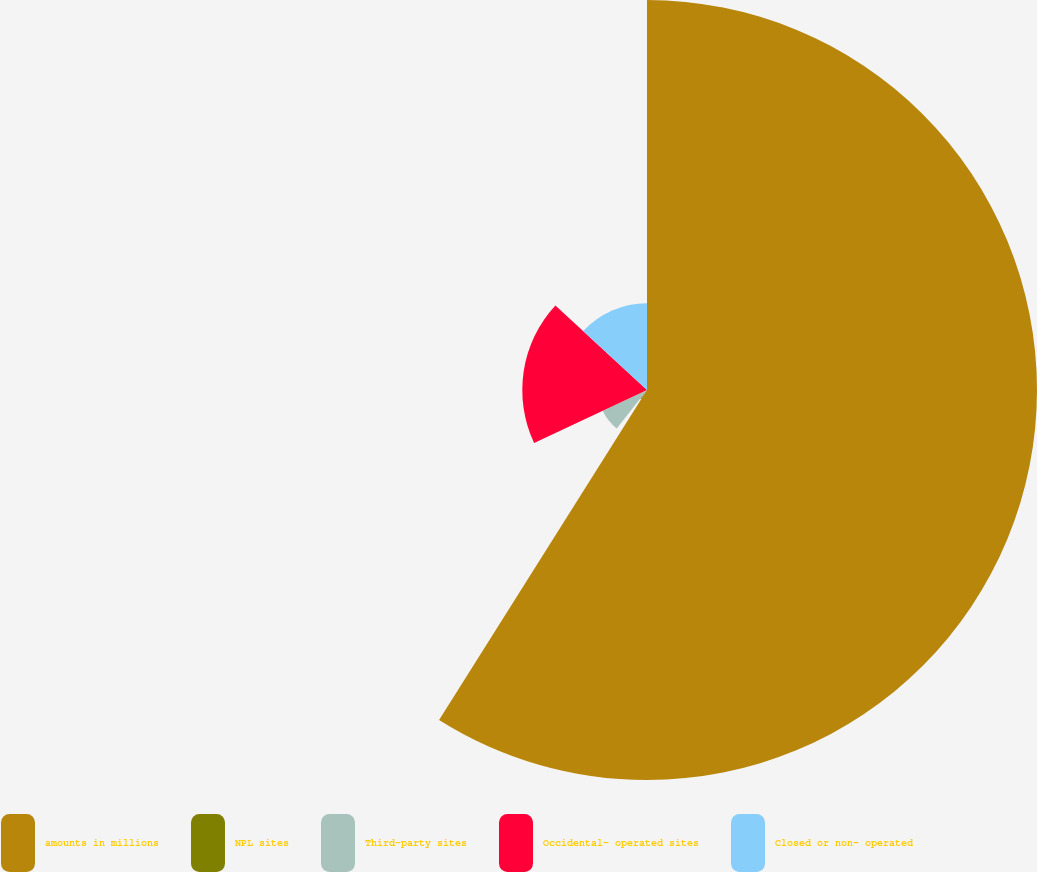<chart> <loc_0><loc_0><loc_500><loc_500><pie_chart><fcel>amounts in millions<fcel>NPL sites<fcel>Third-party sites<fcel>Occidental- operated sites<fcel>Closed or non- operated<nl><fcel>58.95%<fcel>1.67%<fcel>7.4%<fcel>18.85%<fcel>13.13%<nl></chart> 